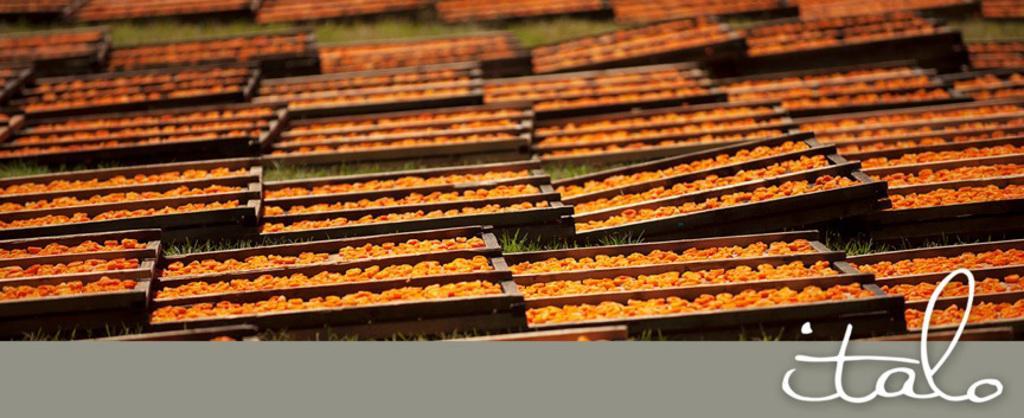Could you give a brief overview of what you see in this image? In the picture we can see a grass surface on it we can see full of trays with grains in it. 